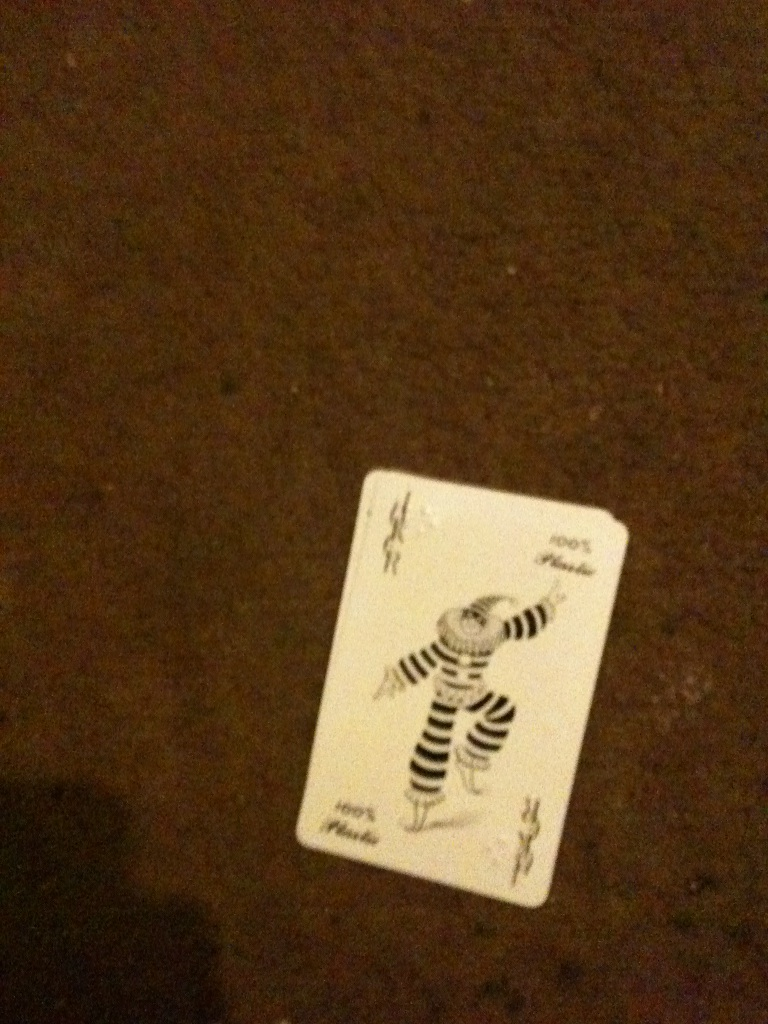If someone were to find this card randomly, what kind of day do you think they might be having? Finding a Joker card randomly might suggest that the person is having an unexpectedly eventful day. Such a discovery could symbolize that they are in for a surprise or a bit of fun, bringing a twist to their routine. The Joker's appearance could act as a reminder not to take life too seriously and to embrace the joy and unpredictability of the moment. 